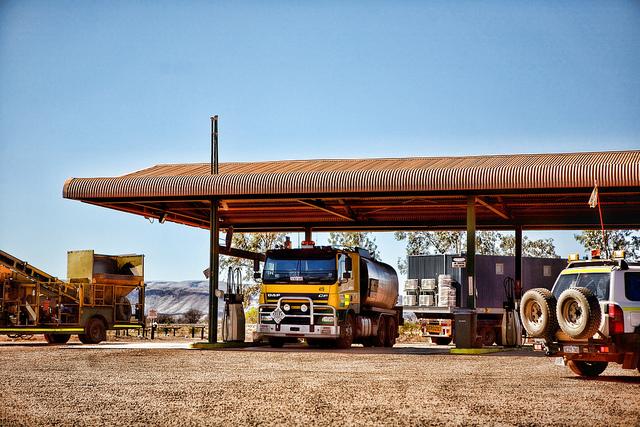Are these vehicles at a fueling station?
Short answer required. Yes. What color is the ground?
Quick response, please. Brown. How many yellow trucks?
Short answer required. 1. 